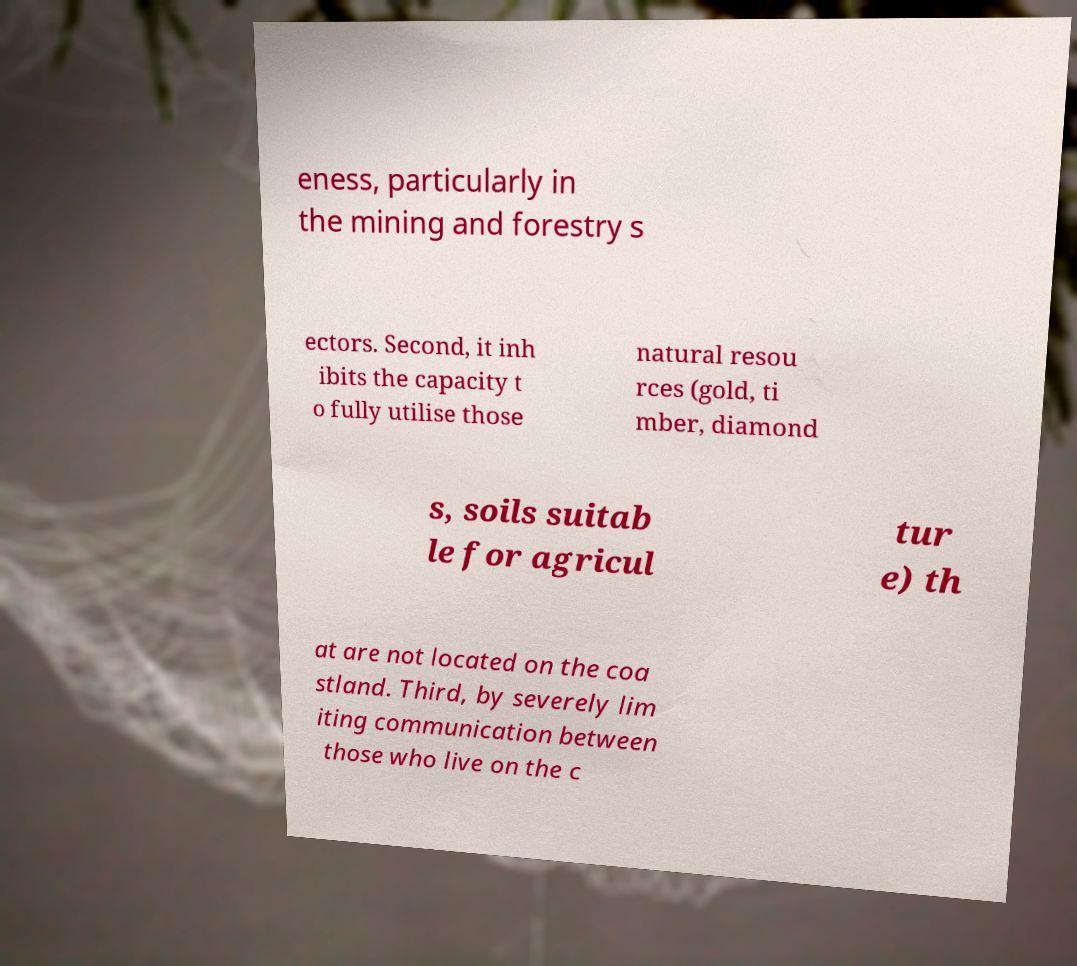Please read and relay the text visible in this image. What does it say? eness, particularly in the mining and forestry s ectors. Second, it inh ibits the capacity t o fully utilise those natural resou rces (gold, ti mber, diamond s, soils suitab le for agricul tur e) th at are not located on the coa stland. Third, by severely lim iting communication between those who live on the c 